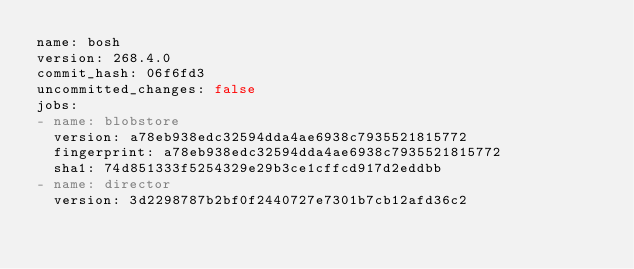<code> <loc_0><loc_0><loc_500><loc_500><_YAML_>name: bosh
version: 268.4.0
commit_hash: 06f6fd3
uncommitted_changes: false
jobs:
- name: blobstore
  version: a78eb938edc32594dda4ae6938c7935521815772
  fingerprint: a78eb938edc32594dda4ae6938c7935521815772
  sha1: 74d851333f5254329e29b3ce1cffcd917d2eddbb
- name: director
  version: 3d2298787b2bf0f2440727e7301b7cb12afd36c2</code> 